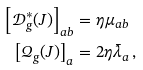Convert formula to latex. <formula><loc_0><loc_0><loc_500><loc_500>\left [ \mathcal { D } _ { g } ^ { \ast } ( J ) \right ] _ { a b } & = \eta \mu _ { a b } \\ \left [ \mathcal { Q } _ { g } ( J ) \right ] _ { a } & = 2 \eta \bar { \lambda } _ { a } \, ,</formula> 